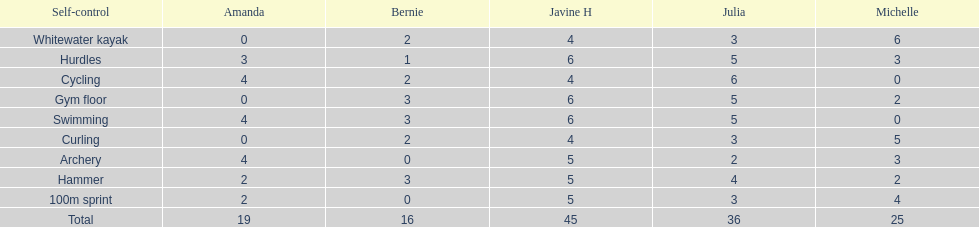Who had her best score in cycling? Julia. 